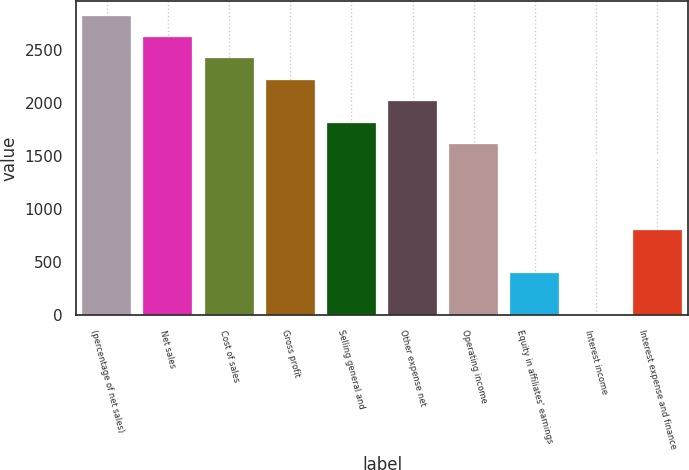Convert chart. <chart><loc_0><loc_0><loc_500><loc_500><bar_chart><fcel>(percentage of net sales)<fcel>Net sales<fcel>Cost of sales<fcel>Gross profit<fcel>Selling general and<fcel>Other expense net<fcel>Operating income<fcel>Equity in affiliates' earnings<fcel>Interest income<fcel>Interest expense and finance<nl><fcel>2822.36<fcel>2620.77<fcel>2419.18<fcel>2217.59<fcel>1814.41<fcel>2016<fcel>1612.82<fcel>403.28<fcel>0.1<fcel>806.46<nl></chart> 